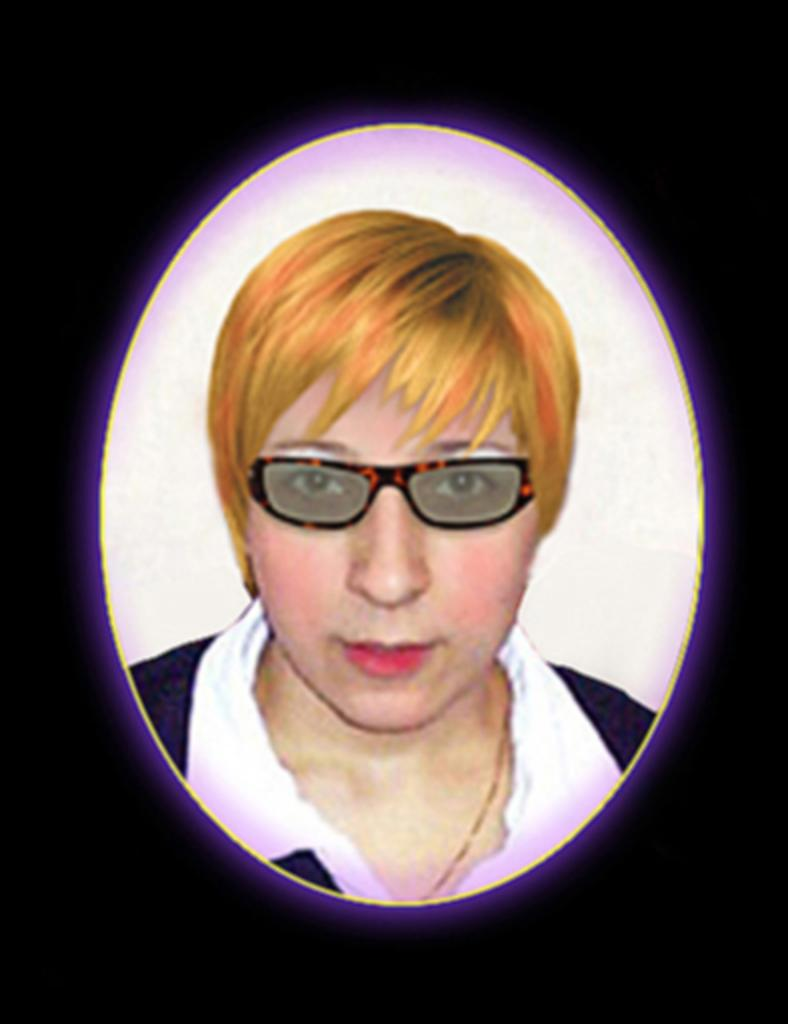Who is present in the image? There is a lady in the image. What is the lady wearing on her face? The lady is wearing glasses. What type of road can be seen in the image? There is no road present in the image; it only features a lady wearing glasses. What kind of stick is the lady holding in the image? There is no stick present in the image; the lady is only wearing glasses. 